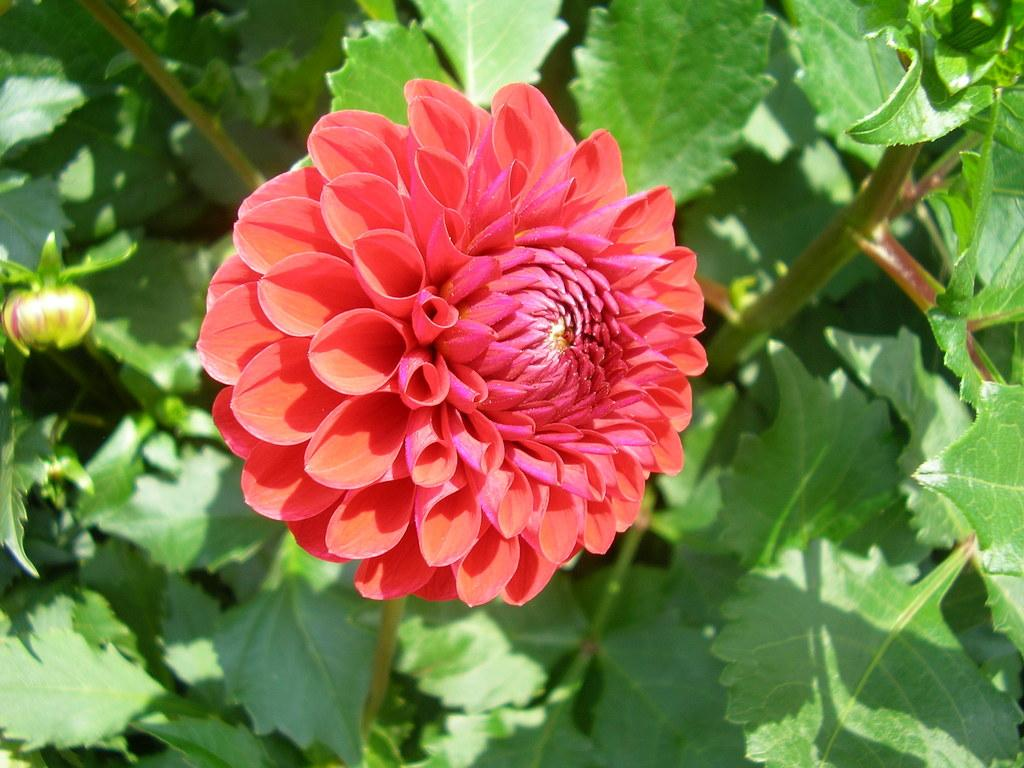What type of flower is present in the image? There is a red flower in the image. What else can be seen in the image besides the red flower? There is a plant in the image. Can you describe the flower bud in the image? There is a flower bud in the left corner of the image. What type of spot can be seen on the flower in the image? There is no spot visible on the flower in the image. 